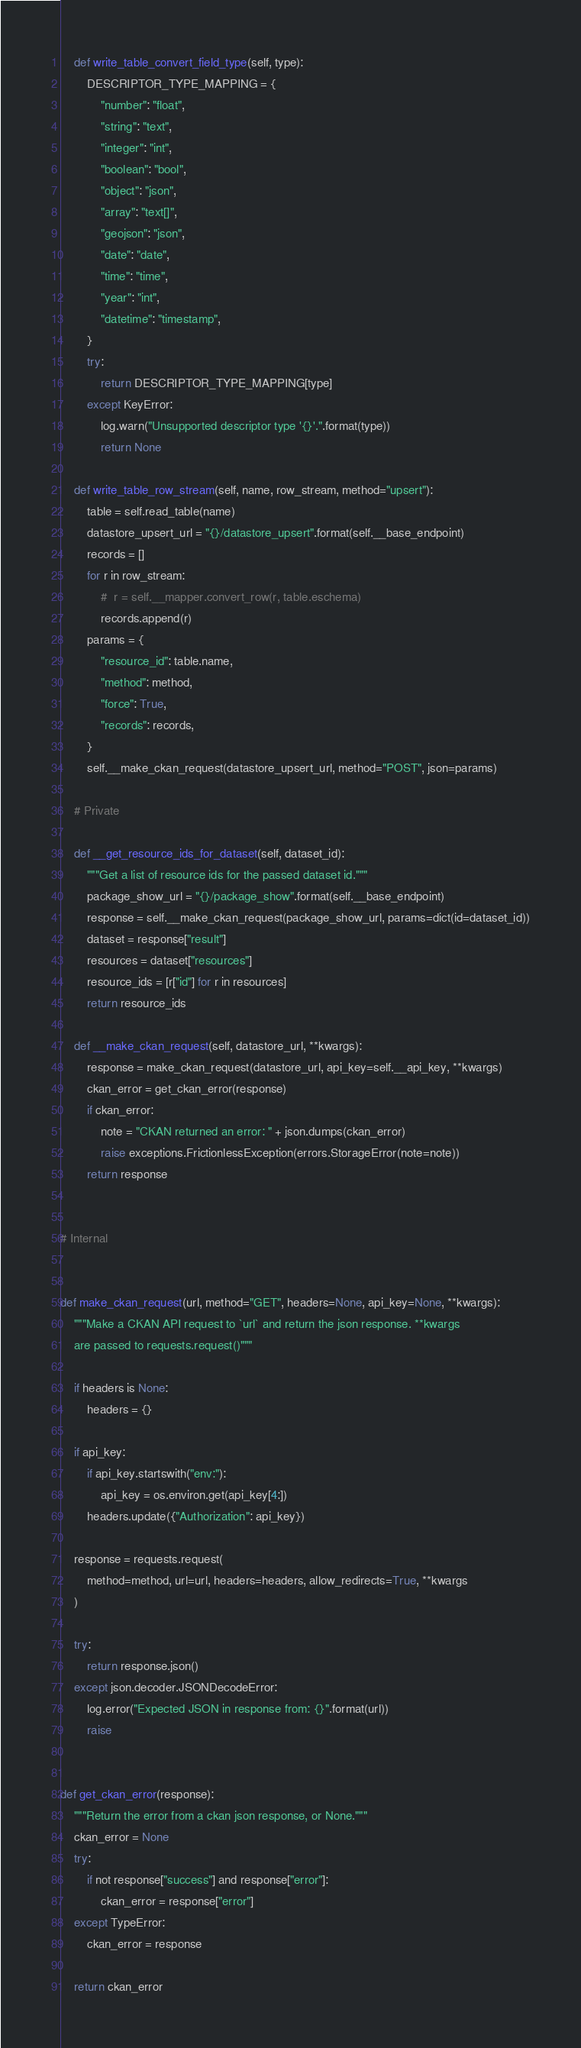Convert code to text. <code><loc_0><loc_0><loc_500><loc_500><_Python_>    def write_table_convert_field_type(self, type):
        DESCRIPTOR_TYPE_MAPPING = {
            "number": "float",
            "string": "text",
            "integer": "int",
            "boolean": "bool",
            "object": "json",
            "array": "text[]",
            "geojson": "json",
            "date": "date",
            "time": "time",
            "year": "int",
            "datetime": "timestamp",
        }
        try:
            return DESCRIPTOR_TYPE_MAPPING[type]
        except KeyError:
            log.warn("Unsupported descriptor type '{}'.".format(type))
            return None

    def write_table_row_stream(self, name, row_stream, method="upsert"):
        table = self.read_table(name)
        datastore_upsert_url = "{}/datastore_upsert".format(self.__base_endpoint)
        records = []
        for r in row_stream:
            #  r = self.__mapper.convert_row(r, table.eschema)
            records.append(r)
        params = {
            "resource_id": table.name,
            "method": method,
            "force": True,
            "records": records,
        }
        self.__make_ckan_request(datastore_upsert_url, method="POST", json=params)

    # Private

    def __get_resource_ids_for_dataset(self, dataset_id):
        """Get a list of resource ids for the passed dataset id."""
        package_show_url = "{}/package_show".format(self.__base_endpoint)
        response = self.__make_ckan_request(package_show_url, params=dict(id=dataset_id))
        dataset = response["result"]
        resources = dataset["resources"]
        resource_ids = [r["id"] for r in resources]
        return resource_ids

    def __make_ckan_request(self, datastore_url, **kwargs):
        response = make_ckan_request(datastore_url, api_key=self.__api_key, **kwargs)
        ckan_error = get_ckan_error(response)
        if ckan_error:
            note = "CKAN returned an error: " + json.dumps(ckan_error)
            raise exceptions.FrictionlessException(errors.StorageError(note=note))
        return response


# Internal


def make_ckan_request(url, method="GET", headers=None, api_key=None, **kwargs):
    """Make a CKAN API request to `url` and return the json response. **kwargs
    are passed to requests.request()"""

    if headers is None:
        headers = {}

    if api_key:
        if api_key.startswith("env:"):
            api_key = os.environ.get(api_key[4:])
        headers.update({"Authorization": api_key})

    response = requests.request(
        method=method, url=url, headers=headers, allow_redirects=True, **kwargs
    )

    try:
        return response.json()
    except json.decoder.JSONDecodeError:
        log.error("Expected JSON in response from: {}".format(url))
        raise


def get_ckan_error(response):
    """Return the error from a ckan json response, or None."""
    ckan_error = None
    try:
        if not response["success"] and response["error"]:
            ckan_error = response["error"]
    except TypeError:
        ckan_error = response

    return ckan_error
</code> 